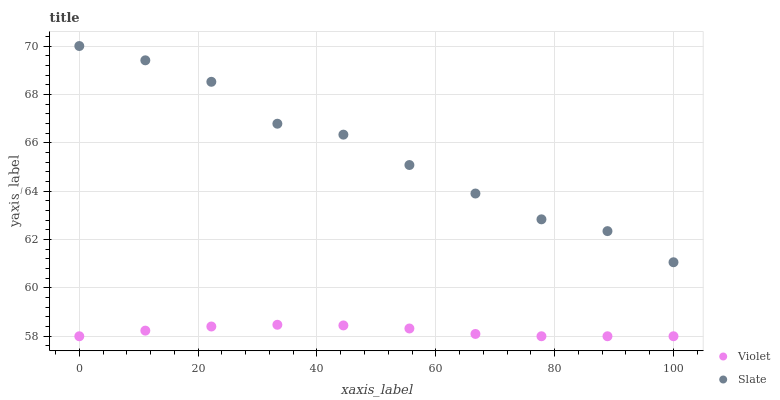Does Violet have the minimum area under the curve?
Answer yes or no. Yes. Does Slate have the maximum area under the curve?
Answer yes or no. Yes. Does Violet have the maximum area under the curve?
Answer yes or no. No. Is Violet the smoothest?
Answer yes or no. Yes. Is Slate the roughest?
Answer yes or no. Yes. Is Violet the roughest?
Answer yes or no. No. Does Violet have the lowest value?
Answer yes or no. Yes. Does Slate have the highest value?
Answer yes or no. Yes. Does Violet have the highest value?
Answer yes or no. No. Is Violet less than Slate?
Answer yes or no. Yes. Is Slate greater than Violet?
Answer yes or no. Yes. Does Violet intersect Slate?
Answer yes or no. No. 